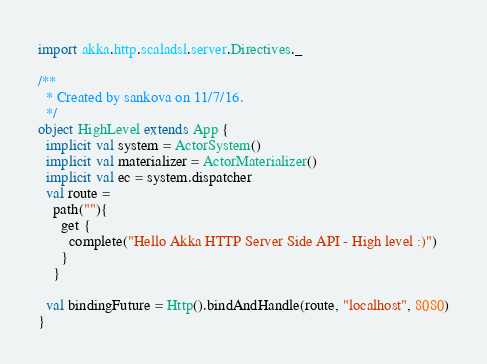Convert code to text. <code><loc_0><loc_0><loc_500><loc_500><_Scala_>import akka.http.scaladsl.server.Directives._

/**
  * Created by sankova on 11/7/16.
  */
object HighLevel extends App {
  implicit val system = ActorSystem()
  implicit val materializer = ActorMaterializer()
  implicit val ec = system.dispatcher
  val route =
    path(""){
      get {
        complete("Hello Akka HTTP Server Side API - High level :)")
      }
    }

  val bindingFuture = Http().bindAndHandle(route, "localhost", 8080)
}
</code> 